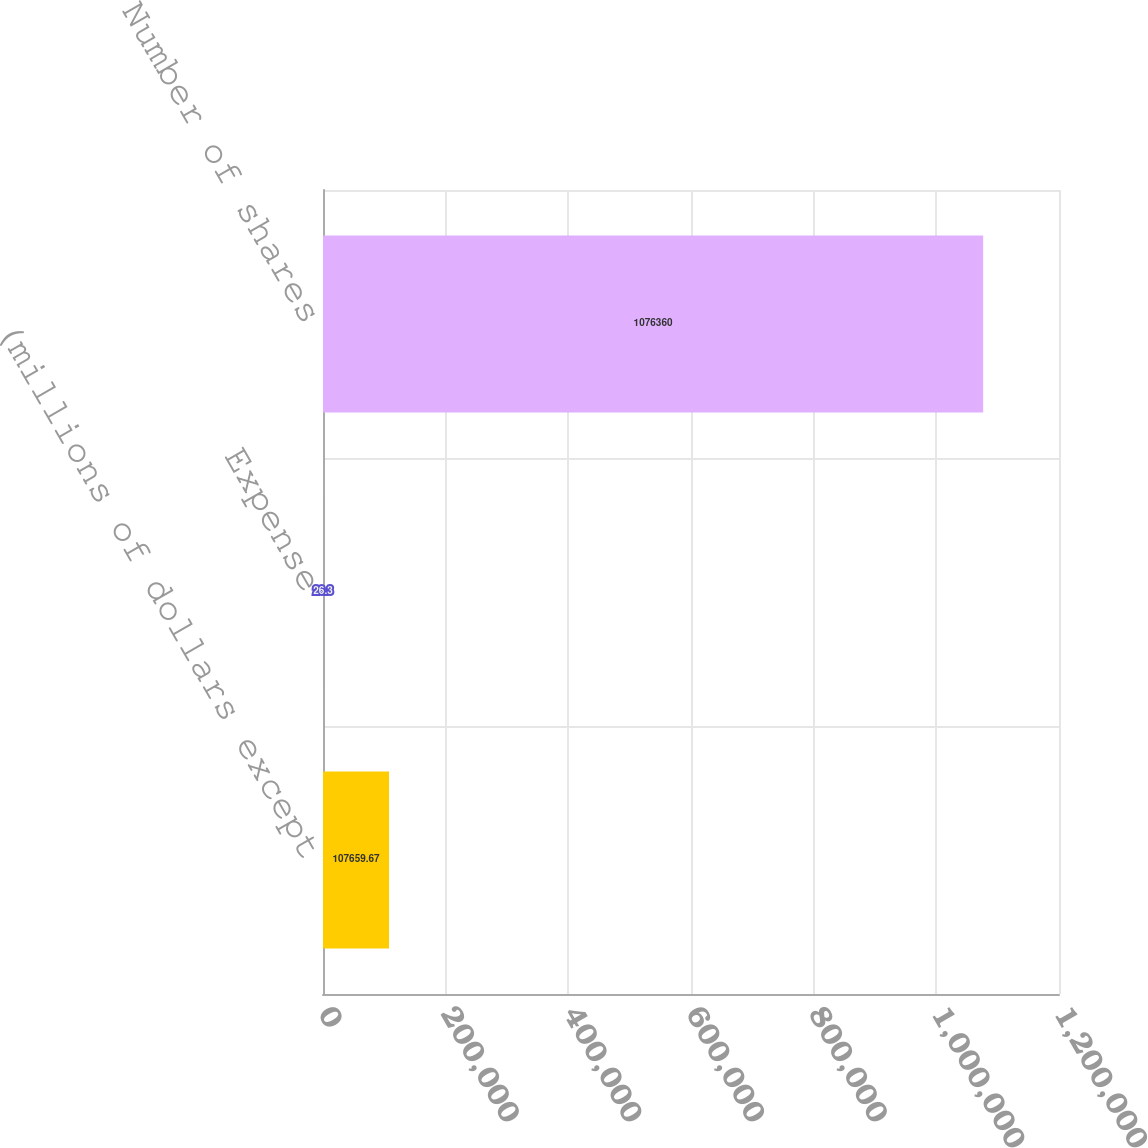Convert chart to OTSL. <chart><loc_0><loc_0><loc_500><loc_500><bar_chart><fcel>(millions of dollars except<fcel>Expense<fcel>Number of shares<nl><fcel>107660<fcel>26.3<fcel>1.07636e+06<nl></chart> 